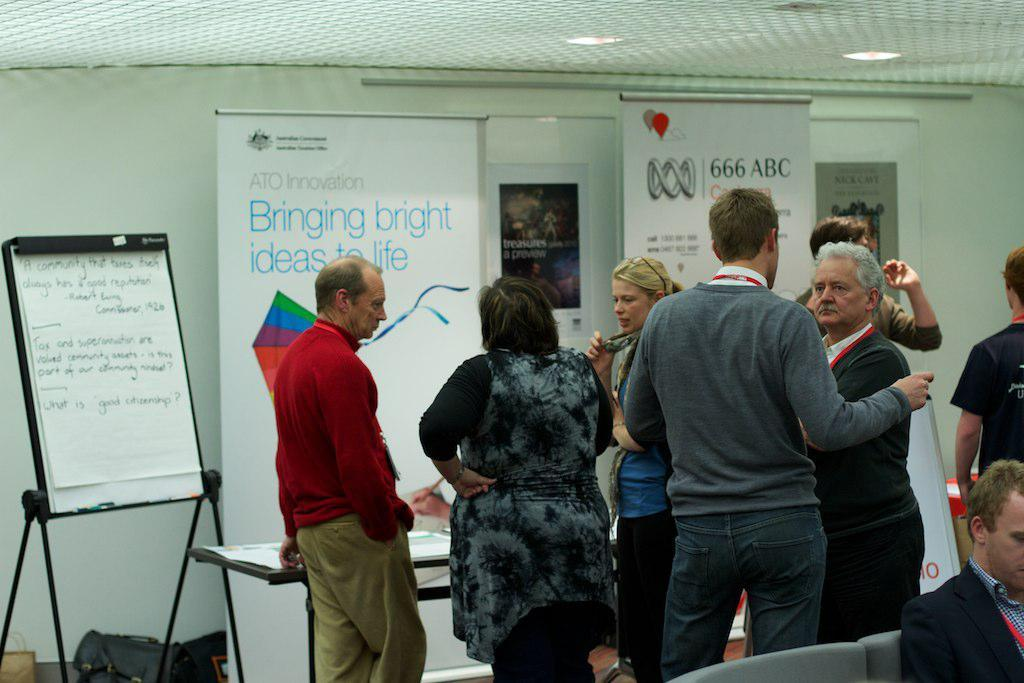What is the main activity of the people in the image? There is a group of people standing in the image, but their activity is not specified. What is the man in the image doing? The man is sitting on a chair in the image. What is on the table in the image? There are papers on the table in the image. What is the purpose of the board in the image? The purpose of the board in the image is not specified. What do the banners in the image indicate? The purpose or message of the banners in the image is not specified. What is the nature of the posts on the wall in the background of the image? The nature of the posts on the wall in the background of the image is not specified. How many pumps are visible in the image? There are no pumps present in the image. What type of air is being used by the people in the image? There is no indication of air usage in the image. What is the can capacity of the table in the image? There is no can present in the image, and the table's capacity is not specified. 